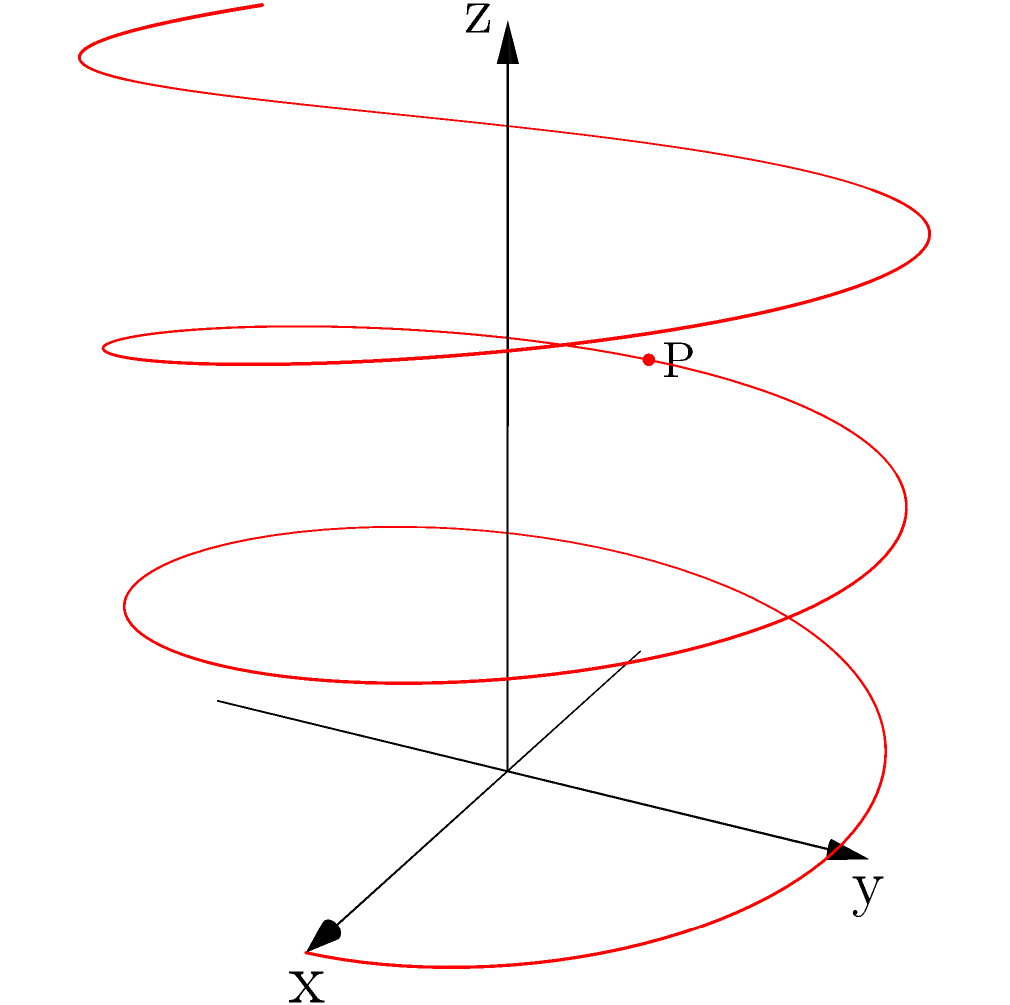In your Broadway debut, your character's movement on stage is represented by the parametric curve:

$$x = 3\cos(t), \quad y = 2\sin(t), \quad z = \frac{t}{3}$$

where $t$ is in radians and $(x,y,z)$ are in meters. At point P, where $t = 3\pi$, what is the magnitude of the velocity vector? To find the magnitude of the velocity vector at point P, we need to follow these steps:

1) The velocity vector is given by:
   $$\vec{v}(t) = \left(\frac{dx}{dt}, \frac{dy}{dt}, \frac{dz}{dt}\right)$$

2) Let's calculate each component:
   $$\frac{dx}{dt} = -3\sin(t)$$
   $$\frac{dy}{dt} = 2\cos(t)$$
   $$\frac{dz}{dt} = \frac{1}{3}$$

3) At $t = 3\pi$, the velocity vector is:
   $$\vec{v}(3\pi) = (-3\sin(3\pi), 2\cos(3\pi), \frac{1}{3})$$
   $$= (0, -2, \frac{1}{3})$$

4) The magnitude of the velocity vector is given by:
   $$\|\vec{v}\| = \sqrt{(\frac{dx}{dt})^2 + (\frac{dy}{dt})^2 + (\frac{dz}{dt})^2}$$

5) Substituting the values:
   $$\|\vec{v}(3\pi)\| = \sqrt{0^2 + (-2)^2 + (\frac{1}{3})^2}$$
   $$= \sqrt{4 + \frac{1}{9}} = \sqrt{\frac{37}{9}}$$

6) Simplifying:
   $$\|\vec{v}(3\pi)\| = \frac{\sqrt{37}}{3} \approx 2.03 \text{ m/s}$$
Answer: $\frac{\sqrt{37}}{3}$ m/s 